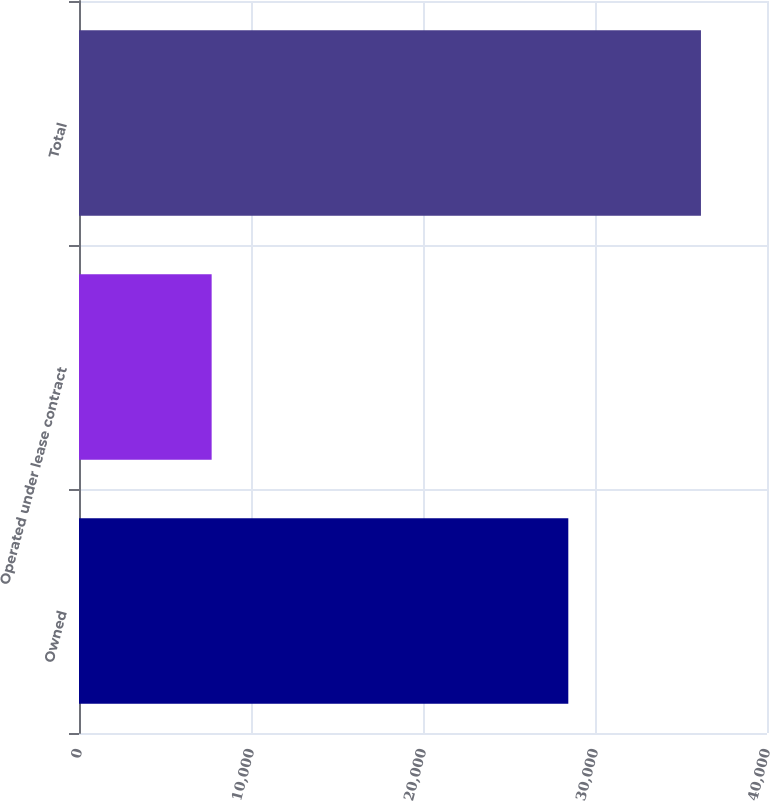Convert chart to OTSL. <chart><loc_0><loc_0><loc_500><loc_500><bar_chart><fcel>Owned<fcel>Operated under lease contract<fcel>Total<nl><fcel>28448<fcel>7712<fcel>36160<nl></chart> 